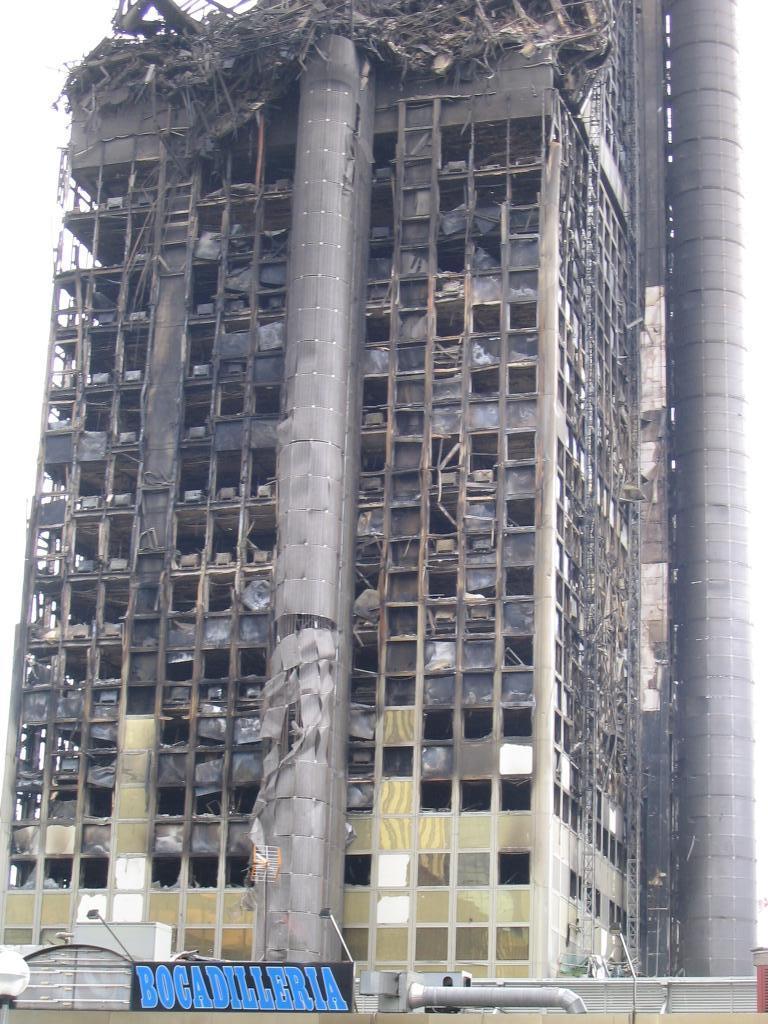Describe this image in one or two sentences. This picture is taken from the outside of the building. In this image, in the middle, we can see a building, window. At the top, we can see a sky, at the bottom, we can see some text. On the right side, we can see a pipe. 